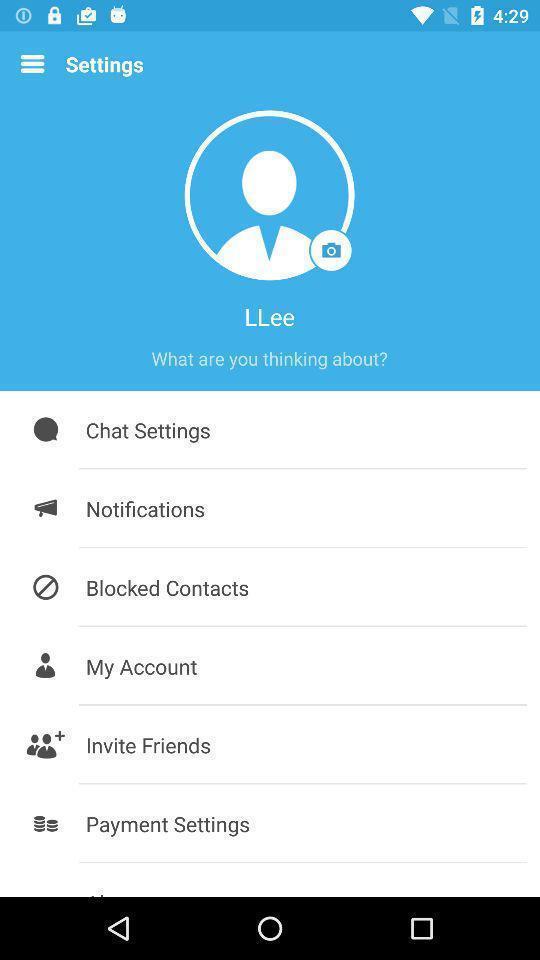Describe the content in this image. Settings page with options in social application. 